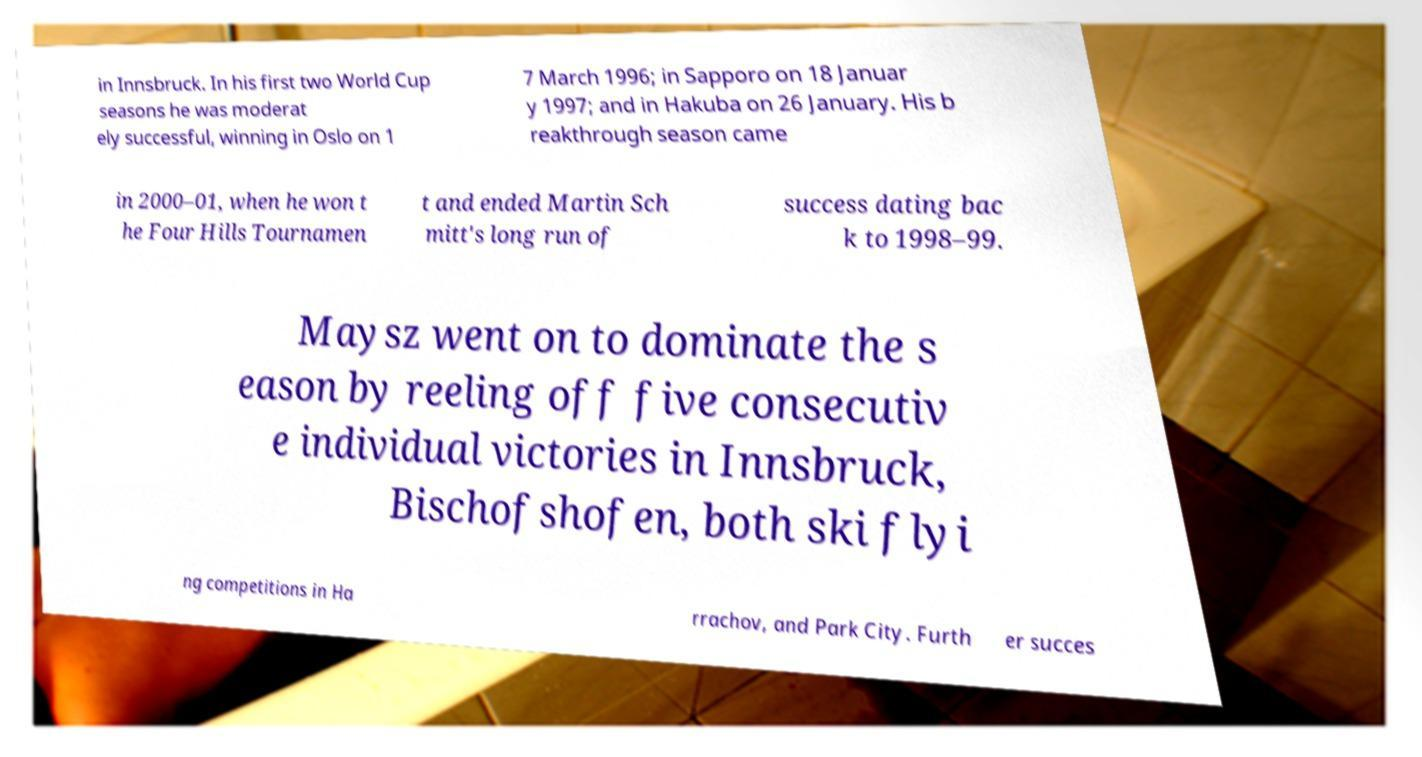Please identify and transcribe the text found in this image. in Innsbruck. In his first two World Cup seasons he was moderat ely successful, winning in Oslo on 1 7 March 1996; in Sapporo on 18 Januar y 1997; and in Hakuba on 26 January. His b reakthrough season came in 2000–01, when he won t he Four Hills Tournamen t and ended Martin Sch mitt's long run of success dating bac k to 1998–99. Maysz went on to dominate the s eason by reeling off five consecutiv e individual victories in Innsbruck, Bischofshofen, both ski flyi ng competitions in Ha rrachov, and Park City. Furth er succes 